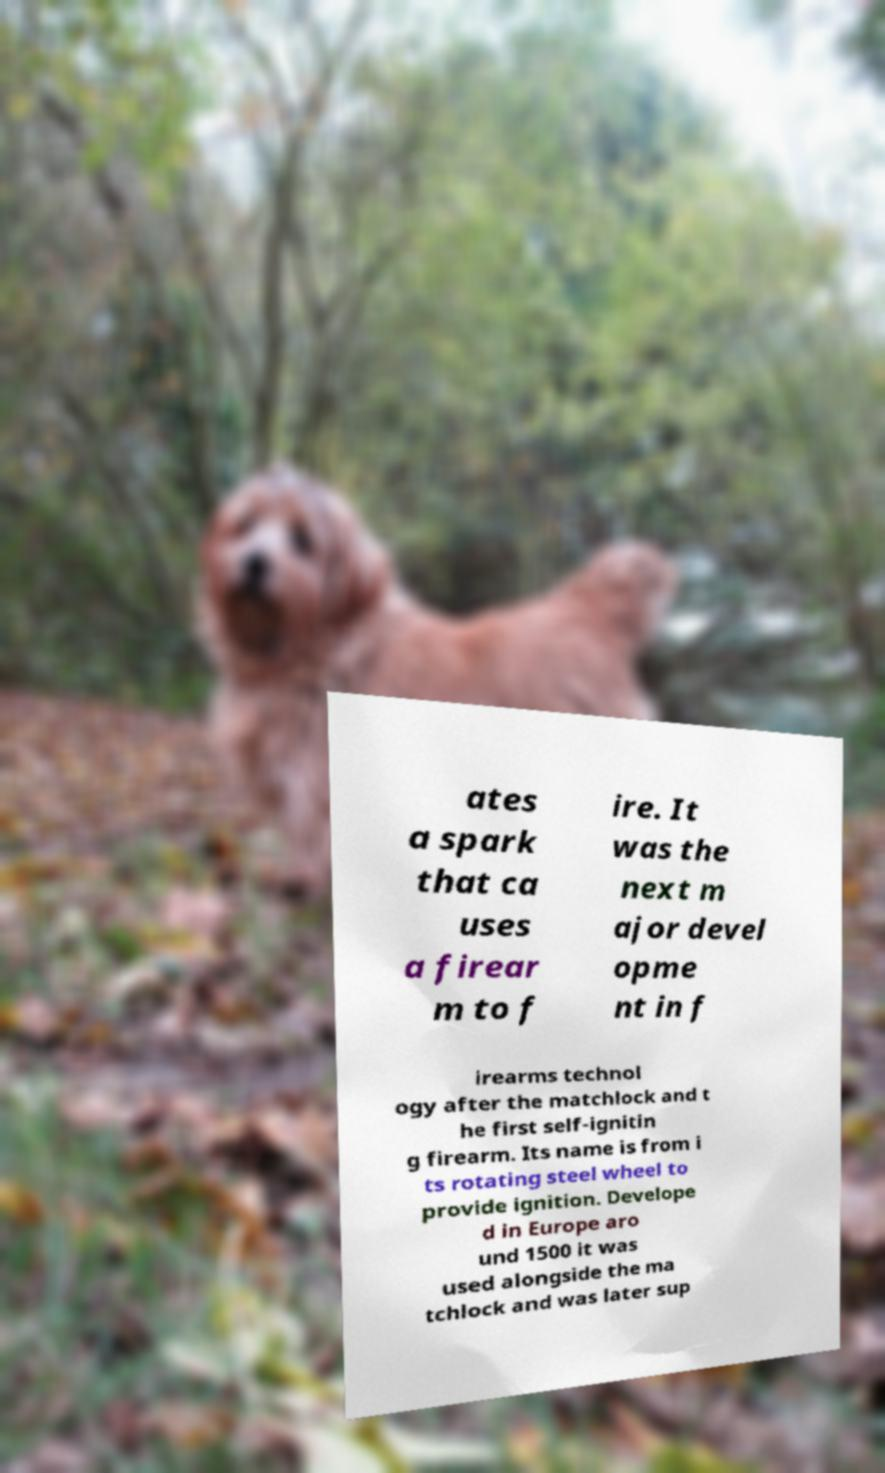Please identify and transcribe the text found in this image. ates a spark that ca uses a firear m to f ire. It was the next m ajor devel opme nt in f irearms technol ogy after the matchlock and t he first self-ignitin g firearm. Its name is from i ts rotating steel wheel to provide ignition. Develope d in Europe aro und 1500 it was used alongside the ma tchlock and was later sup 